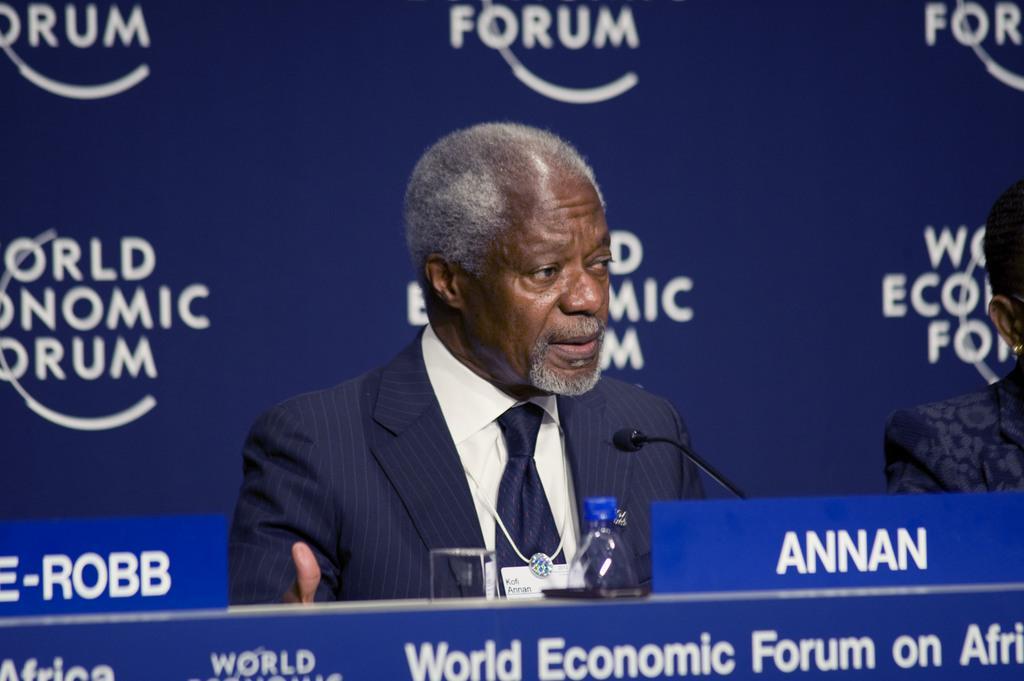Describe this image in one or two sentences. In this image we can see a person, in front of him we can see a podium, on the podium, there is a mic, Bottle and a name board, in the background we can see a poster with some text. 